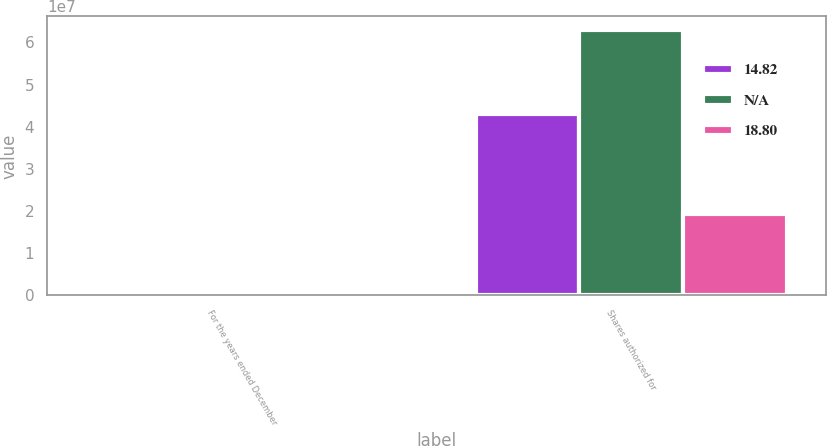<chart> <loc_0><loc_0><loc_500><loc_500><stacked_bar_chart><ecel><fcel>For the years ended December<fcel>Shares authorized for<nl><fcel>14.82<fcel>2013<fcel>4.30716e+07<nl><fcel>nan<fcel>2012<fcel>6.30467e+07<nl><fcel>18.8<fcel>2011<fcel>1.92015e+07<nl></chart> 